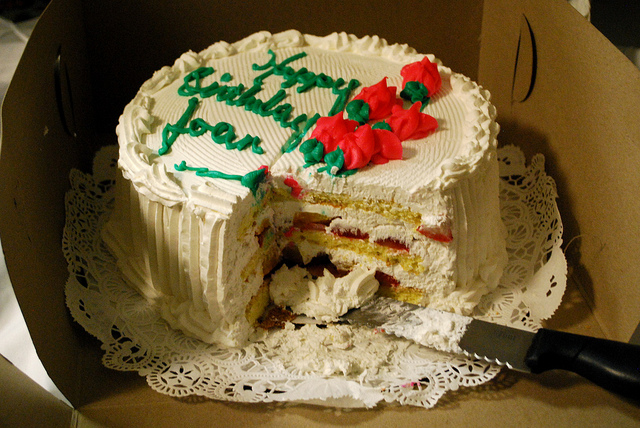Please transcribe the text in this image. Happy Birthday Joan 